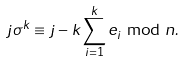Convert formula to latex. <formula><loc_0><loc_0><loc_500><loc_500>j \sigma ^ { k } \equiv j - k \sum _ { i = 1 } ^ { k } e _ { i } \bmod n .</formula> 